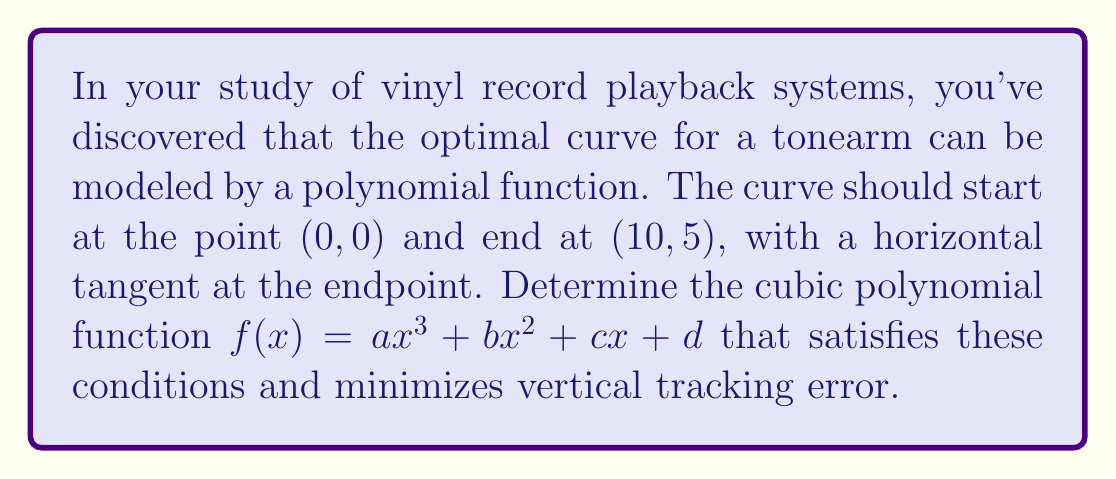Show me your answer to this math problem. Let's approach this step-by-step:

1) We know that $f(x) = ax^3 + bx^2 + cx + d$

2) Given conditions:
   a) $f(0) = 0$
   b) $f(10) = 5$
   c) $f'(10) = 0$ (horizontal tangent at endpoint)

3) From condition (a): $f(0) = d = 0$

4) Now our function is: $f(x) = ax^3 + bx^2 + cx$

5) From condition (b): $f(10) = 5$
   $1000a + 100b + 10c = 5$ ... (Equation 1)

6) For condition (c), we need to find $f'(x)$:
   $f'(x) = 3ax^2 + 2bx + c$
   
   $f'(10) = 0$, so:
   $300a + 20b + c = 0$ ... (Equation 2)

7) To minimize vertical tracking error, we want the curve to be as close to linear as possible. This means we should minimize the coefficient of $x^3$. Let's set $a = -\frac{1}{1000}$.

8) Substituting this into Equation 1:
   $-1 + 100b + 10c = 5$
   $100b + 10c = 6$ ... (Equation 3)

9) Substituting $a = -\frac{1}{1000}$ into Equation 2:
   $-0.3 + 20b + c = 0$
   $20b + c = 0.3$ ... (Equation 4)

10) Solving Equations 3 and 4 simultaneously:
    From Equation 4: $c = 0.3 - 20b$
    Substituting into Equation 3:
    $100b + 10(0.3 - 20b) = 6$
    $100b + 3 - 200b = 6$
    $-100b = 3$
    $b = -0.03$

11) Now we can find $c$:
    $c = 0.3 - 20(-0.03) = 0.9$

Therefore, the optimal cubic polynomial function is:
$f(x) = -\frac{1}{1000}x^3 - 0.03x^2 + 0.9x$
Answer: $f(x) = -0.001x^3 - 0.03x^2 + 0.9x$ 